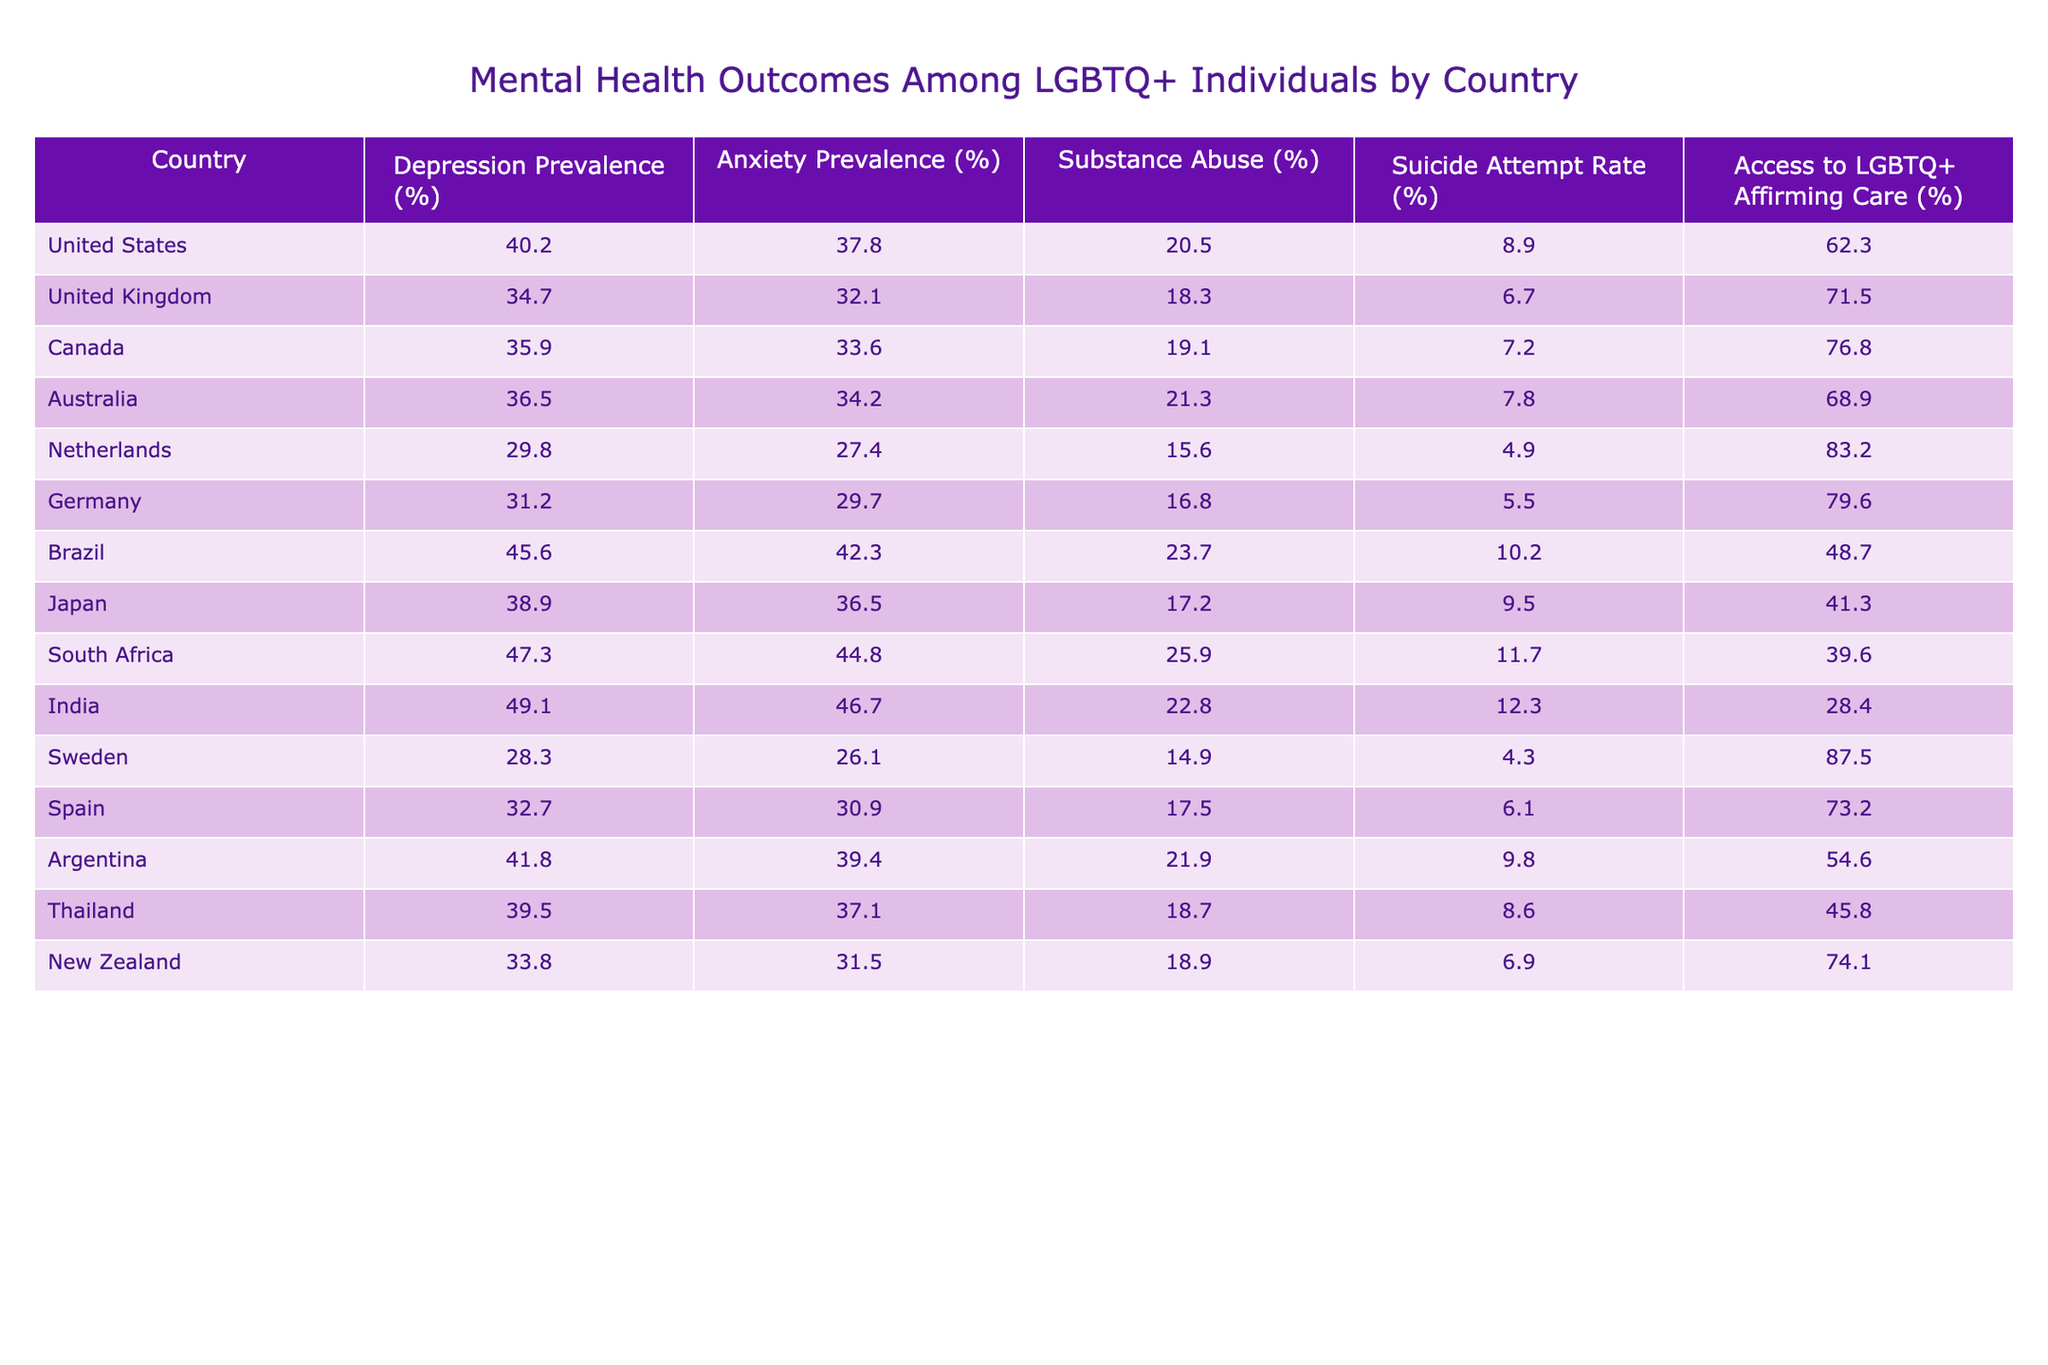What is the prevalence of depression among LGBTQ+ individuals in Canada? The table shows that the depression prevalence in Canada is listed as 35.9%.
Answer: 35.9% Which country has the highest suicide attempt rate among LGBTQ+ individuals? The table indicates that India has the highest suicide attempt rate at 12.3%.
Answer: 12.3% What is the average anxiety prevalence among the countries listed in the table? To find the average, add the anxiety prevalence rates: (37.8 + 32.1 + 33.6 + 34.2 + 27.4 + 29.7 + 42.3 + 36.5 + 44.8 + 46.7 + 26.1 + 30.9 + 39.4 + 37.1 + 31.5) = 635.4. There are 15 data points, so the average is 635.4 / 15 = 42.36%.
Answer: 42.4% Does the Netherlands have a higher access to LGBTQ+ affirming care than Brazil? According to the table, the Netherlands has 83.2% access while Brazil has 48.7%, indicating that the Netherlands does indeed have higher access.
Answer: Yes If we compare the depression prevalence in South Africa and Argentina, which one is higher? The table shows South Africa's prevalence at 47.3% and Argentina's at 41.8%, so South Africa has a higher prevalence.
Answer: South Africa What is the difference in substance abuse rates between Australia and Germany? Australia has a substance abuse rate of 21.3% and Germany has 16.8%. The difference is 21.3 - 16.8 = 4.5%.
Answer: 4.5% Is the access to LGBTQ+ affirming care in the United Kingdom greater than in Japan? The table lists access for the United Kingdom at 71.5% and Japan at 41.3%. Therefore, the United Kingdom does have greater access.
Answer: Yes What country shows the lowest prevalence of anxiety among LGBTQ+ individuals? The table indicates that Sweden has the lowest anxiety prevalence at 26.1%.
Answer: Sweden What is the median depression prevalence among the countries in this table? To find the median, first, arrange the depression prevalence values: 29.8, 31.2, 34.7, 35.9, 36.5, 40.2, 41.8, 45.6, 47.3, 49.1. The median is the average of the two middle numbers (35.9 and 36.5), which is (35.9 + 36.5) / 2 = 36.2%.
Answer: 36.2% Which two countries have the closest rates of suicide attempt? Looking at the table, Brazil has a suicide attempt rate of 10.2% and the United Kingdom has 6.7%. The difference is 3.5%, indicating they are quite close.
Answer: Brazil and the United Kingdom 